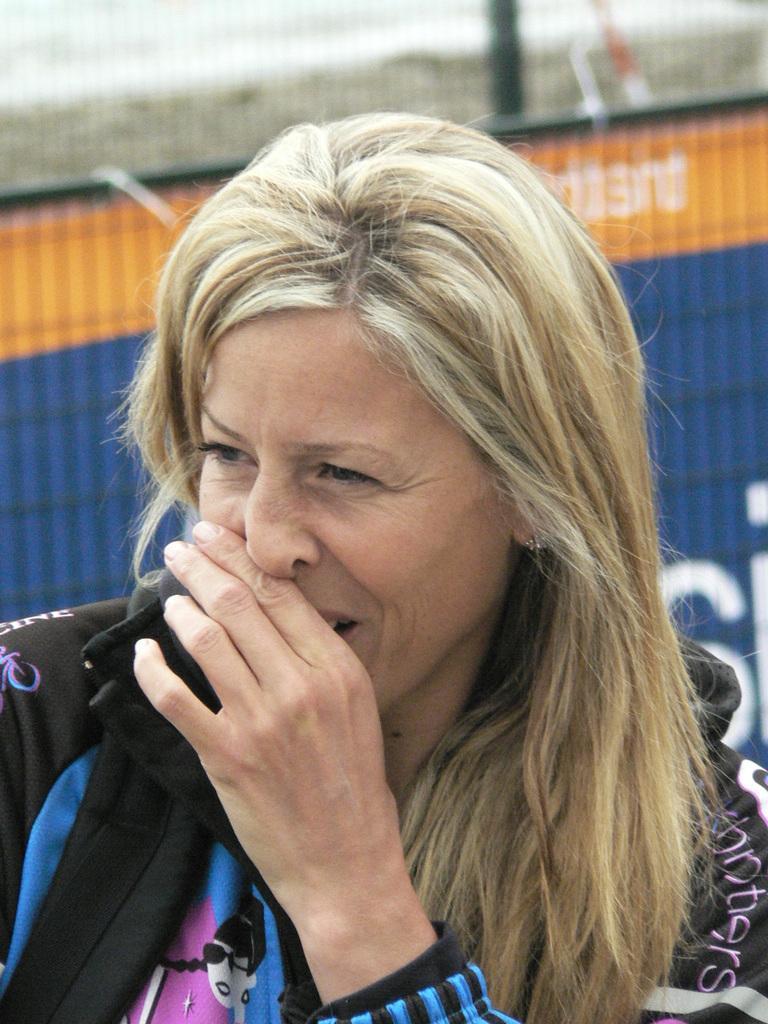Describe this image in one or two sentences. In this image I can see a woman and other objects. The background of the image is blurred. 